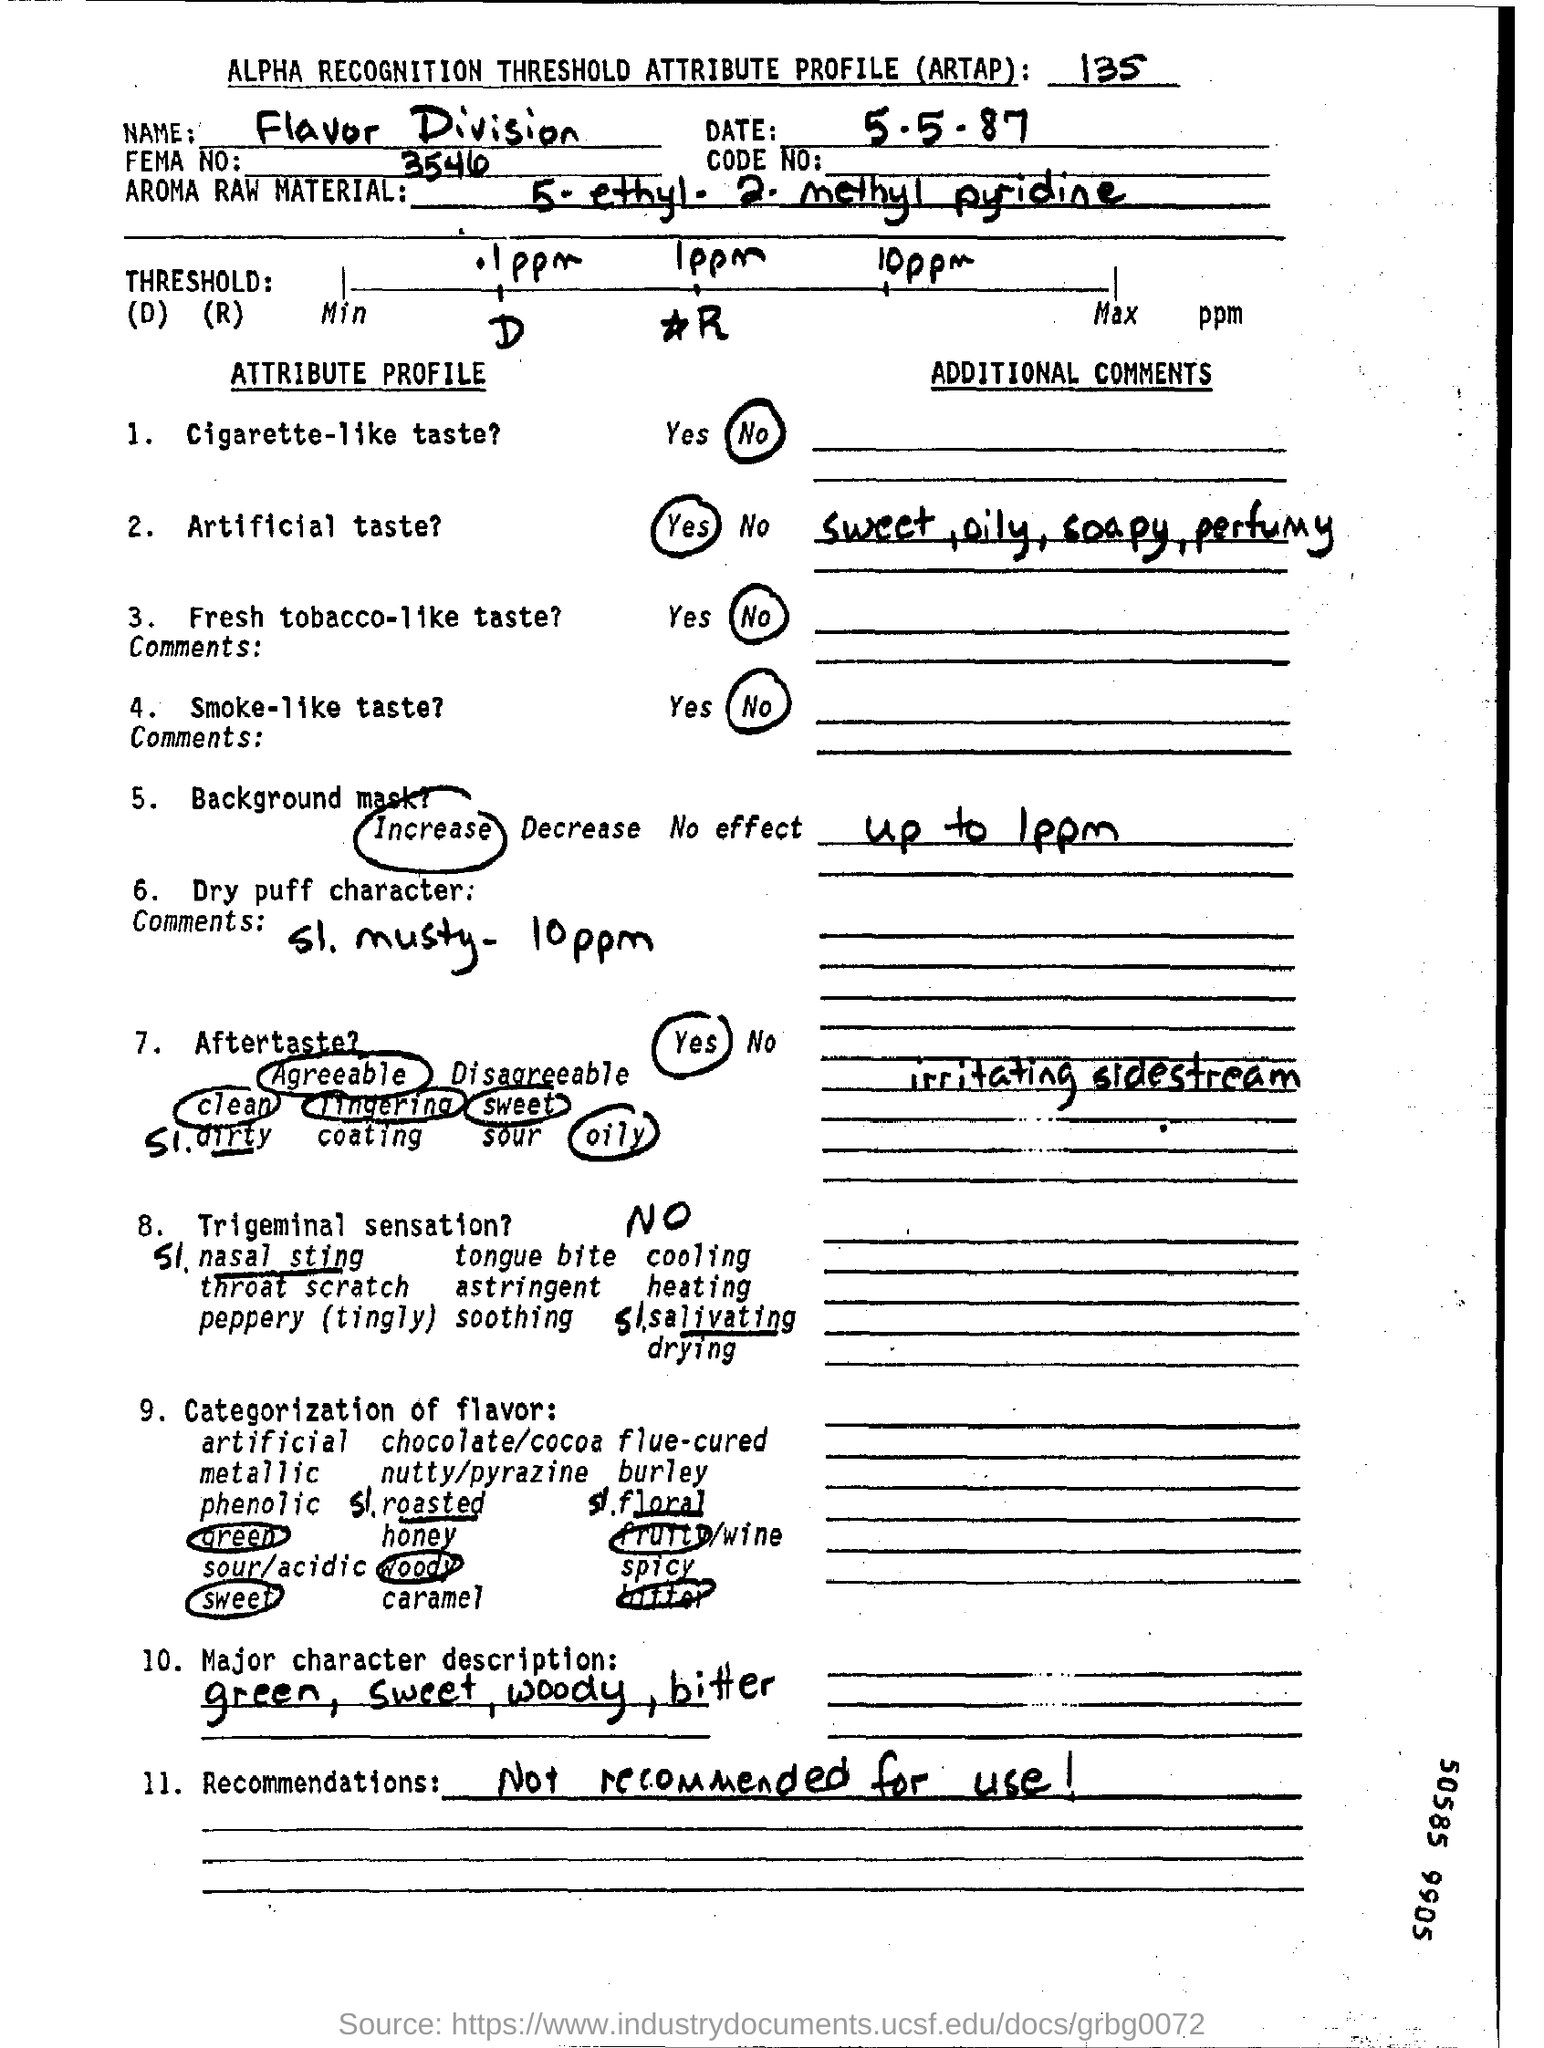What is the date mentioned in the top of the document ?
Your answer should be compact. 5-5-87. Which Name written in the Name field ?
Keep it short and to the point. Flavor division. What is written in the Recommendations Field ?
Your answer should be very brief. Not recommended for use!. 